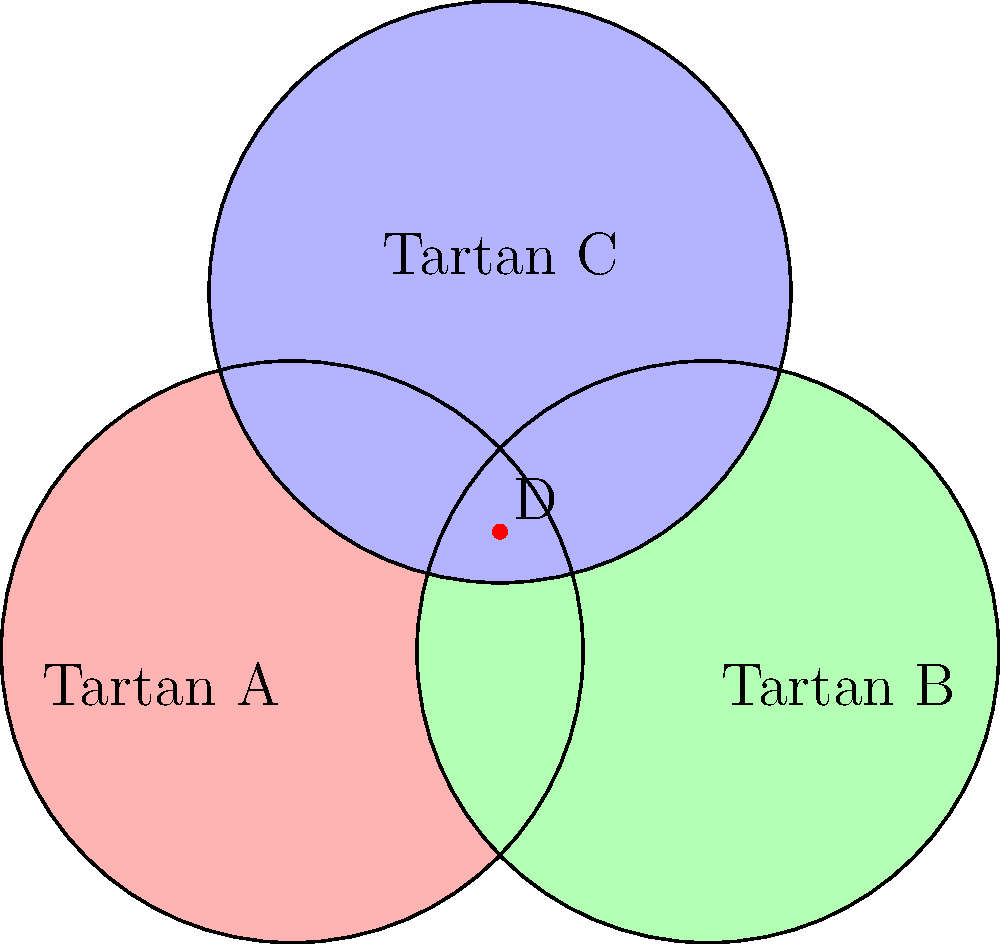As a tartan weaver, you're planning to create three different tartans (A, B, and C) using the same set of yarns. The Venn diagram above represents the overlap of yarn colors used in each tartan. If you want to maximize yarn efficiency by choosing a color combination that appears in the most tartans, which region should you focus on? What is the maximum number of tartans that can share a single color combination? To solve this problem, we need to analyze the Venn diagram and understand what each region represents:

1. The circles represent the yarn colors used in each tartan (A, B, and C).
2. The overlapping regions represent color combinations shared between tartans.
3. We need to find the region that is shared by the most tartans.

Let's examine each region:
- Regions outside all circles: Not shared by any tartan
- Regions inside only one circle: Used by only one tartan
- Regions where two circles overlap: Shared by two tartans
- Region where all three circles overlap: Shared by all three tartans

The region where all three circles overlap (point D in the diagram) represents color combinations used in all three tartans. This is the region that maximizes yarn efficiency as it allows you to use the same colors for all three tartans.

Therefore, focusing on the color combinations in region D will allow you to use the same yarns across all three tartans, maximizing efficiency.

The maximum number of tartans that can share a single color combination is 3, which occurs in the region where all circles overlap (region D).
Answer: Region D; 3 tartans 